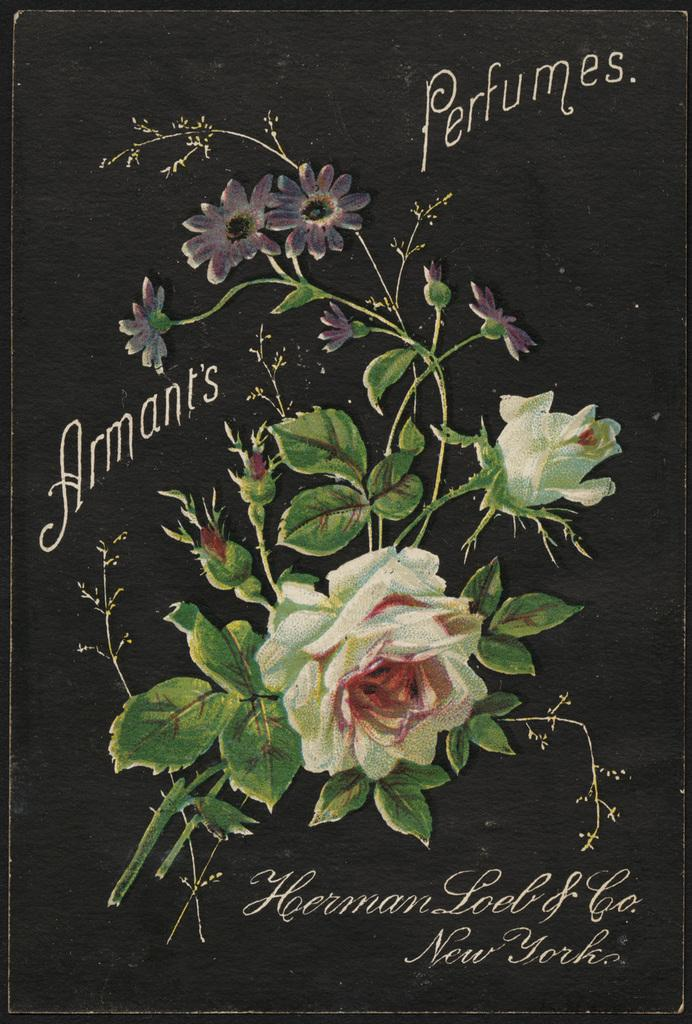What type of artwork is featured in the image? The image contains beautiful paintings of flowers. What color is used as the background in the paintings? The background of the paintings is black. What additional details can be seen in the paintings? There are names around the flowers in the paintings. How much sugar is present in the cable depicted in the image? There is no cable present in the image, and therefore no sugar can be associated with it. 